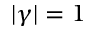<formula> <loc_0><loc_0><loc_500><loc_500>| \gamma | = 1</formula> 